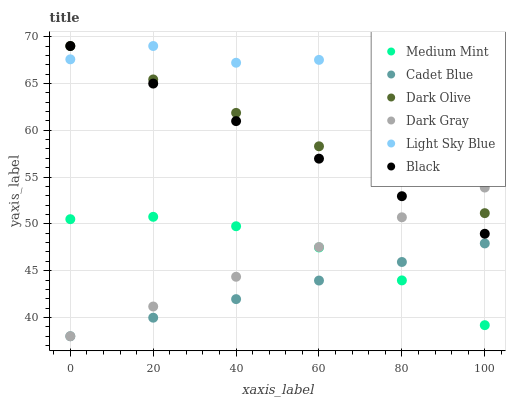Does Cadet Blue have the minimum area under the curve?
Answer yes or no. Yes. Does Light Sky Blue have the maximum area under the curve?
Answer yes or no. Yes. Does Dark Olive have the minimum area under the curve?
Answer yes or no. No. Does Dark Olive have the maximum area under the curve?
Answer yes or no. No. Is Dark Gray the smoothest?
Answer yes or no. Yes. Is Light Sky Blue the roughest?
Answer yes or no. Yes. Is Cadet Blue the smoothest?
Answer yes or no. No. Is Cadet Blue the roughest?
Answer yes or no. No. Does Cadet Blue have the lowest value?
Answer yes or no. Yes. Does Dark Olive have the lowest value?
Answer yes or no. No. Does Black have the highest value?
Answer yes or no. Yes. Does Cadet Blue have the highest value?
Answer yes or no. No. Is Medium Mint less than Dark Olive?
Answer yes or no. Yes. Is Dark Olive greater than Medium Mint?
Answer yes or no. Yes. Does Light Sky Blue intersect Dark Olive?
Answer yes or no. Yes. Is Light Sky Blue less than Dark Olive?
Answer yes or no. No. Is Light Sky Blue greater than Dark Olive?
Answer yes or no. No. Does Medium Mint intersect Dark Olive?
Answer yes or no. No. 